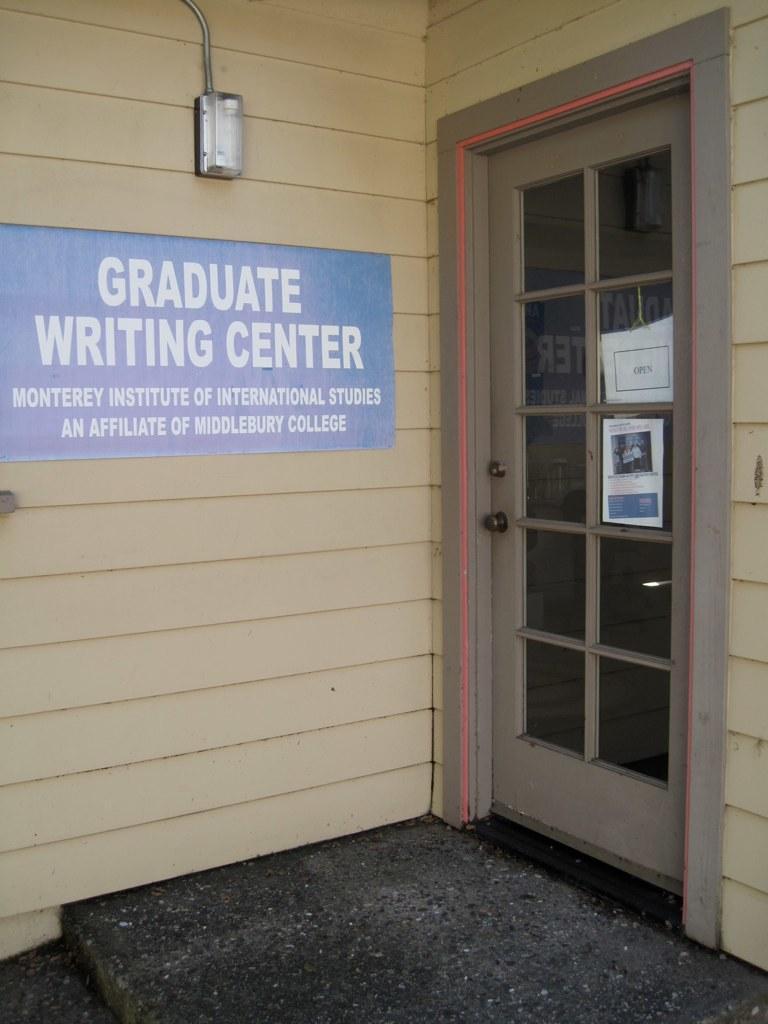How would you summarize this image in a sentence or two? In the picture I can see a blue color board which is fixed to the wall on which we can see some text. Here we can see the light and glass door. 